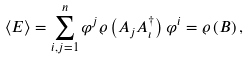<formula> <loc_0><loc_0><loc_500><loc_500>\left \langle E \right \rangle = \sum _ { i , j = 1 } ^ { n } \varphi ^ { j } \varrho \left ( A _ { j } A _ { \iota } ^ { \dagger } \right ) \varphi ^ { i } = \varrho \left ( B \right ) ,</formula> 